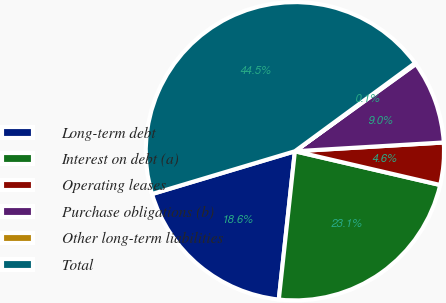Convert chart. <chart><loc_0><loc_0><loc_500><loc_500><pie_chart><fcel>Long-term debt<fcel>Interest on debt (a)<fcel>Operating leases<fcel>Purchase obligations (b)<fcel>Other long-term liabilities<fcel>Total<nl><fcel>18.65%<fcel>23.09%<fcel>4.57%<fcel>9.01%<fcel>0.13%<fcel>44.55%<nl></chart> 